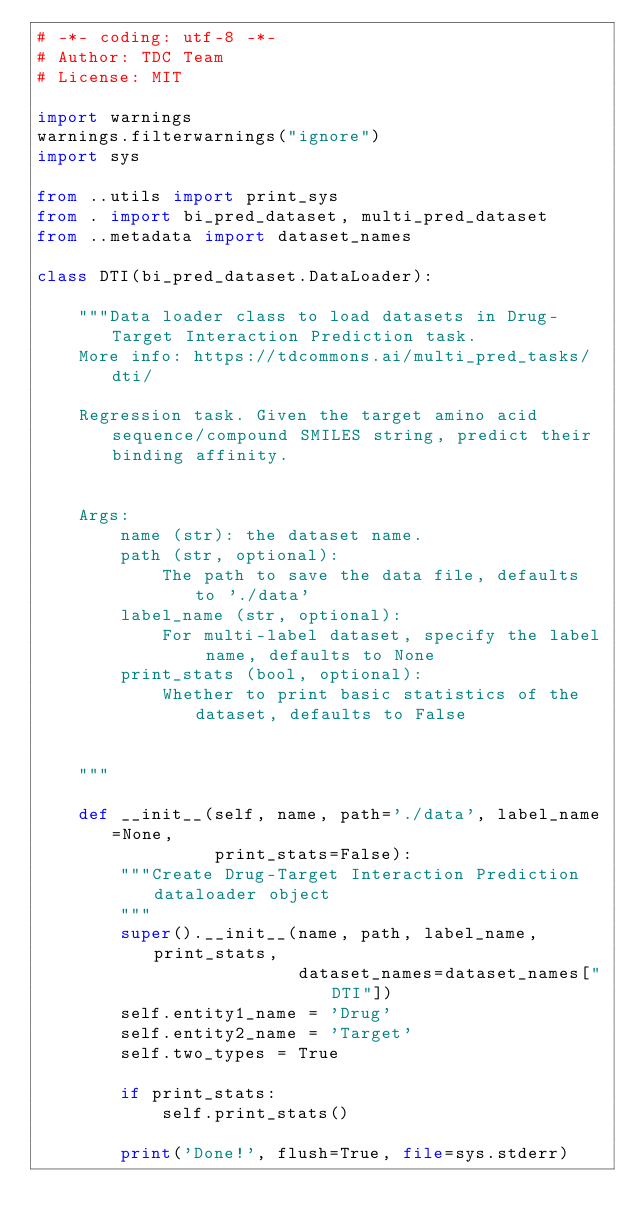<code> <loc_0><loc_0><loc_500><loc_500><_Python_># -*- coding: utf-8 -*-
# Author: TDC Team
# License: MIT

import warnings
warnings.filterwarnings("ignore")
import sys

from ..utils import print_sys
from . import bi_pred_dataset, multi_pred_dataset
from ..metadata import dataset_names

class DTI(bi_pred_dataset.DataLoader):

    """Data loader class to load datasets in Drug-Target Interaction Prediction task. 
    More info: https://tdcommons.ai/multi_pred_tasks/dti/

    Regression task. Given the target amino acid sequence/compound SMILES string, predict their binding affinity.


    Args:
        name (str): the dataset name.
        path (str, optional): 
            The path to save the data file, defaults to './data'
        label_name (str, optional): 
            For multi-label dataset, specify the label name, defaults to None
        print_stats (bool, optional): 
            Whether to print basic statistics of the dataset, defaults to False

    
    """
    
    def __init__(self, name, path='./data', label_name=None,
                 print_stats=False):
        """Create Drug-Target Interaction Prediction dataloader object
        """
        super().__init__(name, path, label_name, print_stats,
                         dataset_names=dataset_names["DTI"])
        self.entity1_name = 'Drug'
        self.entity2_name = 'Target'
        self.two_types = True

        if print_stats:
            self.print_stats()

        print('Done!', flush=True, file=sys.stderr)</code> 